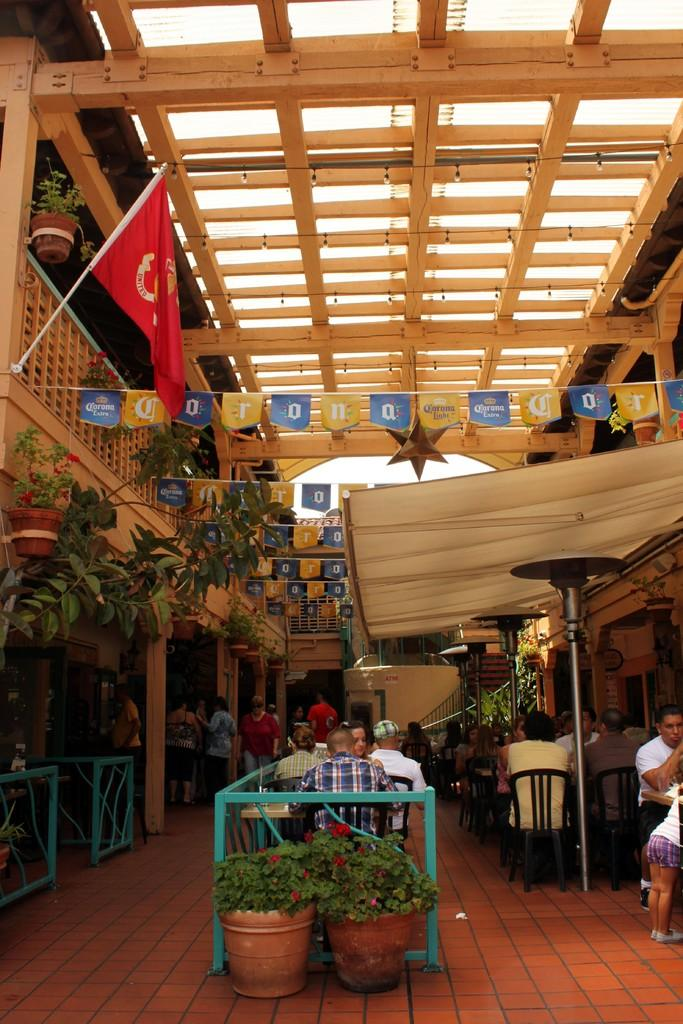What objects are present in the image that are typically used for cooking or storage? There are pots in the image, which are commonly used for cooking or storage. What symbol or emblem can be seen in the image? There is a flag in the image, which often represents a country, organization, or cause. What items in the image might be used for reading or writing? There are pages in the image, which are typically used for reading or writing. What type of natural vegetation is visible in the image? There are trees and plants in the image, which are examples of natural vegetation. What are the people in the image doing? There are people sitting on chairs in the image, suggesting they might be resting or engaged in a conversation. What type of material is present in the image that is white in color? There is a white color cloth in the image, which could be used for various purposes such as covering or decoration. Where is the cave located in the image? There is no cave present in the image. What type of transportation can be seen in the image? There is no transportation, such as a train, present in the image. 